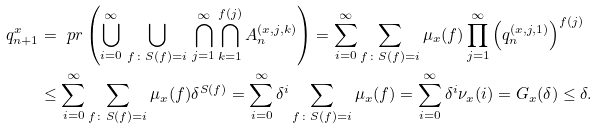<formula> <loc_0><loc_0><loc_500><loc_500>q _ { n + 1 } ^ { x } & = \ p r \left ( \bigcup _ { i = 0 } ^ { \infty } \, \bigcup _ { f \colon S ( f ) = i } \, \bigcap _ { j = 1 } ^ { \infty } \bigcap _ { k = 1 } ^ { f ( j ) } A _ { n } ^ { ( x , j , k ) } \right ) = \sum _ { i = 0 } ^ { \infty } \sum _ { f \colon S ( f ) = i } \mu _ { x } ( f ) \prod _ { j = 1 } ^ { \infty } \left ( q _ { n } ^ { ( x , j , 1 ) } \right ) ^ { f ( j ) } \\ & \leq \sum _ { i = 0 } ^ { \infty } \sum _ { f \colon S ( f ) = i } \mu _ { x } ( f ) \delta ^ { S ( f ) } = \sum _ { i = 0 } ^ { \infty } \delta ^ { i } \sum _ { f \colon S ( f ) = i } \mu _ { x } ( f ) = \sum _ { i = 0 } ^ { \infty } \delta ^ { i } \nu _ { x } ( i ) = G _ { x } ( \delta ) \leq \delta .</formula> 